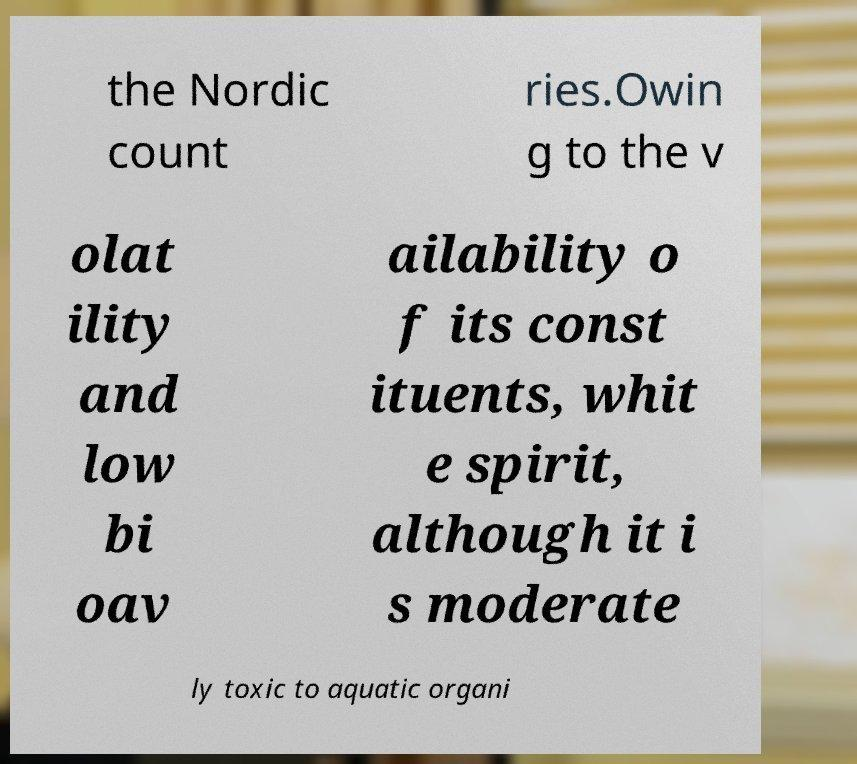Can you read and provide the text displayed in the image?This photo seems to have some interesting text. Can you extract and type it out for me? the Nordic count ries.Owin g to the v olat ility and low bi oav ailability o f its const ituents, whit e spirit, although it i s moderate ly toxic to aquatic organi 